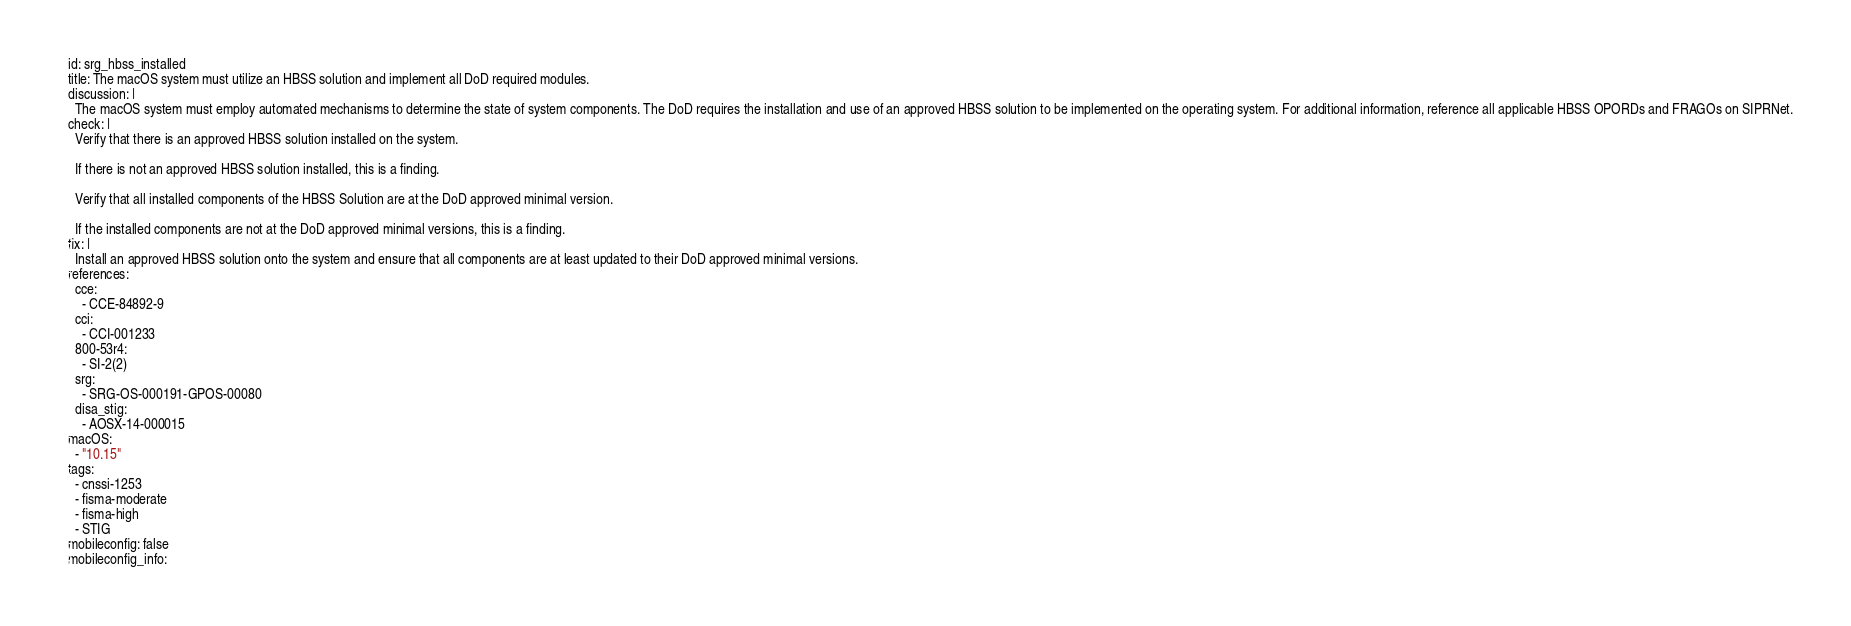<code> <loc_0><loc_0><loc_500><loc_500><_YAML_>id: srg_hbss_installed
title: The macOS system must utilize an HBSS solution and implement all DoD required modules.
discussion: |
  The macOS system must employ automated mechanisms to determine the state of system components. The DoD requires the installation and use of an approved HBSS solution to be implemented on the operating system. For additional information, reference all applicable HBSS OPORDs and FRAGOs on SIPRNet.
check: |
  Verify that there is an approved HBSS solution installed on the system.
  
  If there is not an approved HBSS solution installed, this is a finding.
  
  Verify that all installed components of the HBSS Solution are at the DoD approved minimal version.
  
  If the installed components are not at the DoD approved minimal versions, this is a finding.
fix: |
  Install an approved HBSS solution onto the system and ensure that all components are at least updated to their DoD approved minimal versions.
references:
  cce:
    - CCE-84892-9
  cci:
    - CCI-001233
  800-53r4:
    - SI-2(2)
  srg:
    - SRG-OS-000191-GPOS-00080
  disa_stig:
    - AOSX-14-000015
macOS:
  - "10.15"
tags:
  - cnssi-1253
  - fisma-moderate
  - fisma-high
  - STIG
mobileconfig: false
mobileconfig_info:</code> 